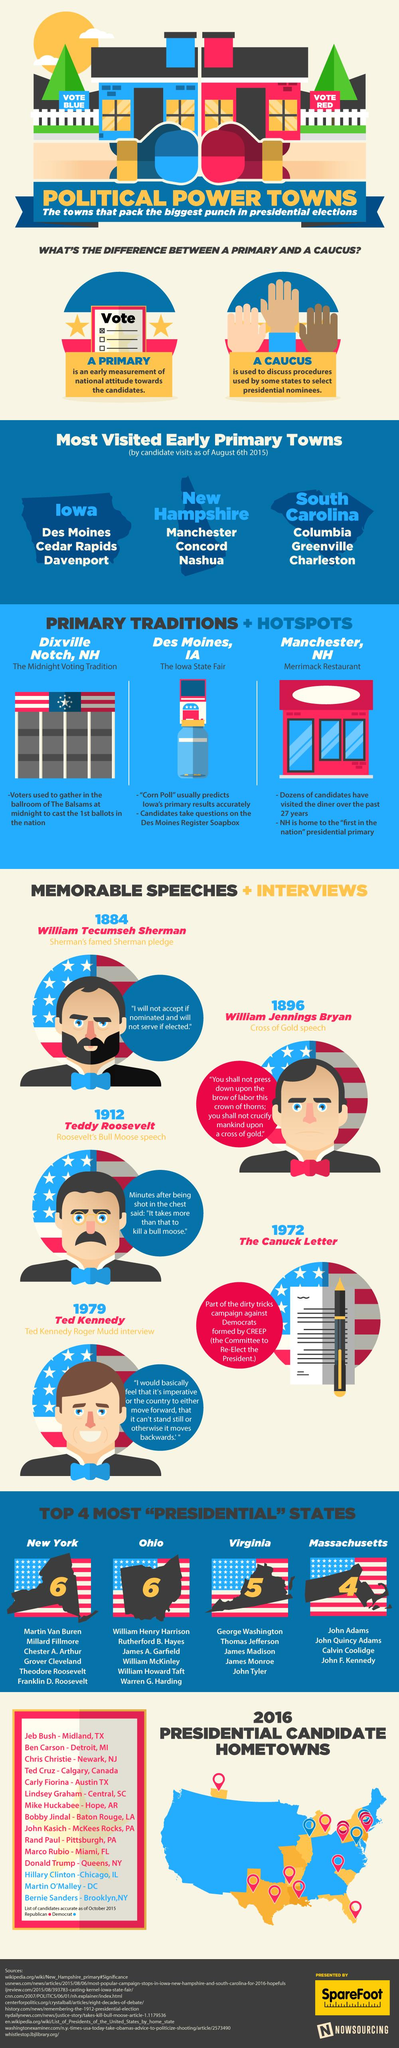List a handful of essential elements in this visual. New Hampshire is the state that has the midnight voting tradition. The cities of Columbia, Greenville, and Charleston belong to the state of South Carolina. New York and Ohio have had the most number of President-elects. 